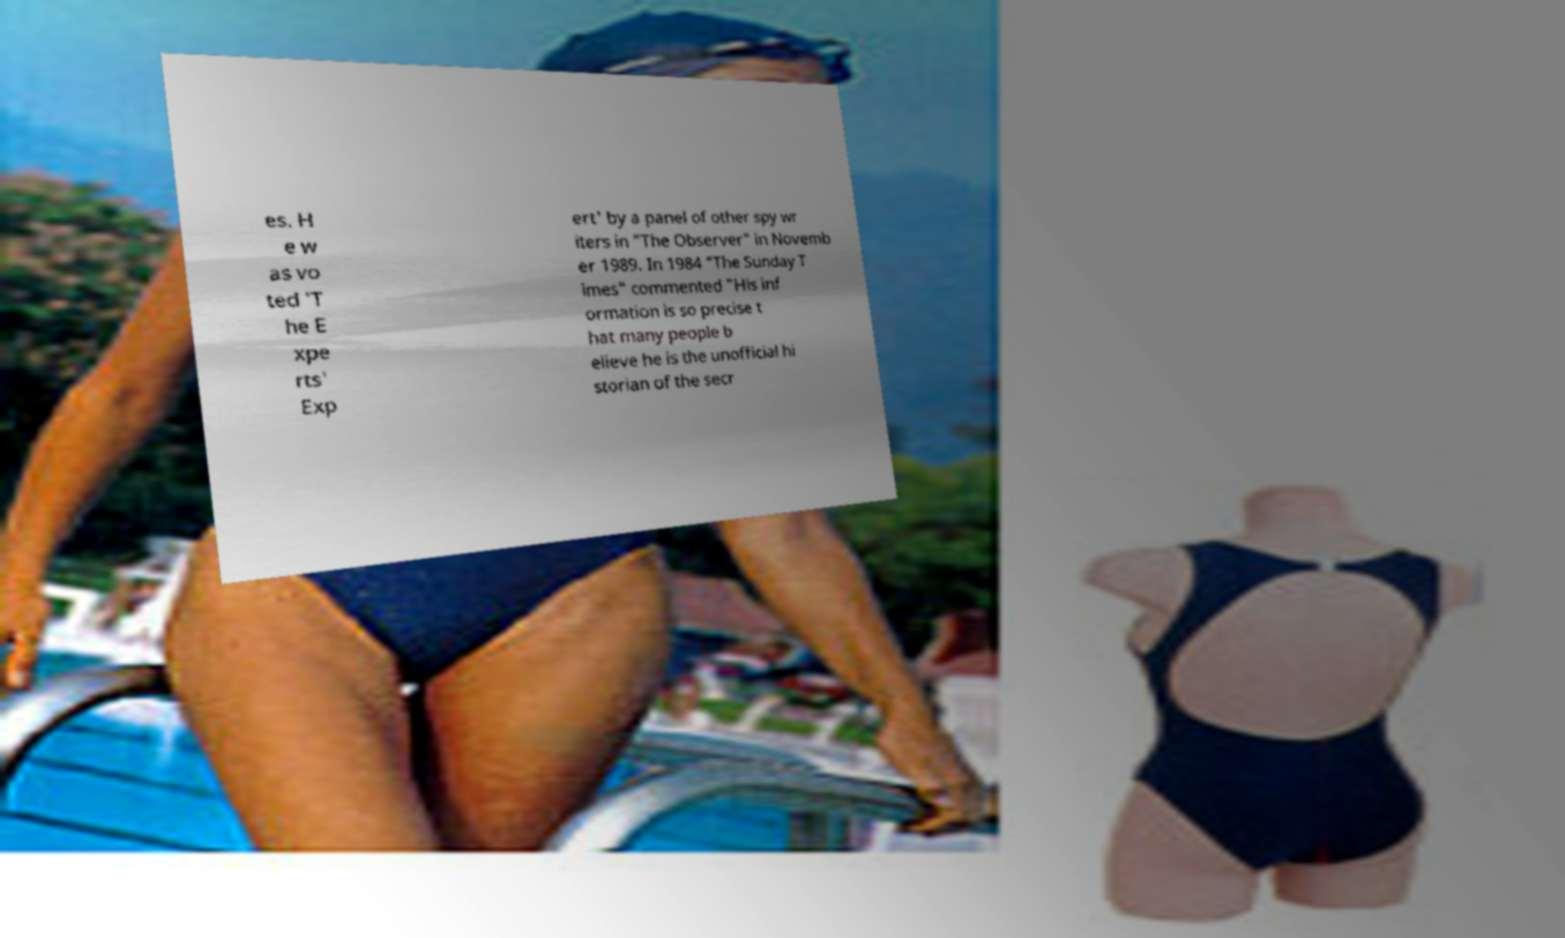What messages or text are displayed in this image? I need them in a readable, typed format. es. H e w as vo ted 'T he E xpe rts' Exp ert' by a panel of other spy wr iters in "The Observer" in Novemb er 1989. In 1984 "The Sunday T imes" commented "His inf ormation is so precise t hat many people b elieve he is the unofficial hi storian of the secr 